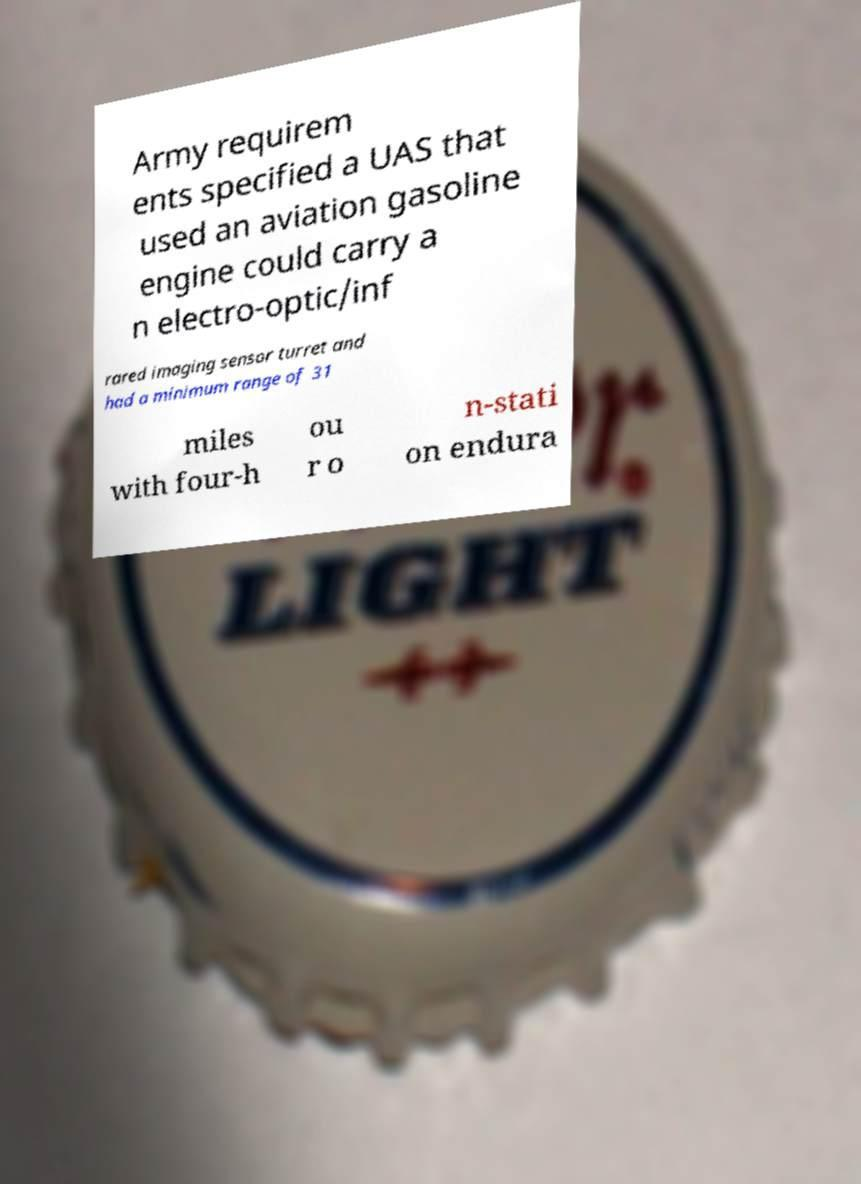Please identify and transcribe the text found in this image. Army requirem ents specified a UAS that used an aviation gasoline engine could carry a n electro-optic/inf rared imaging sensor turret and had a minimum range of 31 miles with four-h ou r o n-stati on endura 